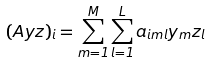Convert formula to latex. <formula><loc_0><loc_0><loc_500><loc_500>( A { y z } ) _ { i } = \sum _ { m = 1 } ^ { M } \sum _ { l = 1 } ^ { L } a _ { i m l } y _ { m } z _ { l }</formula> 